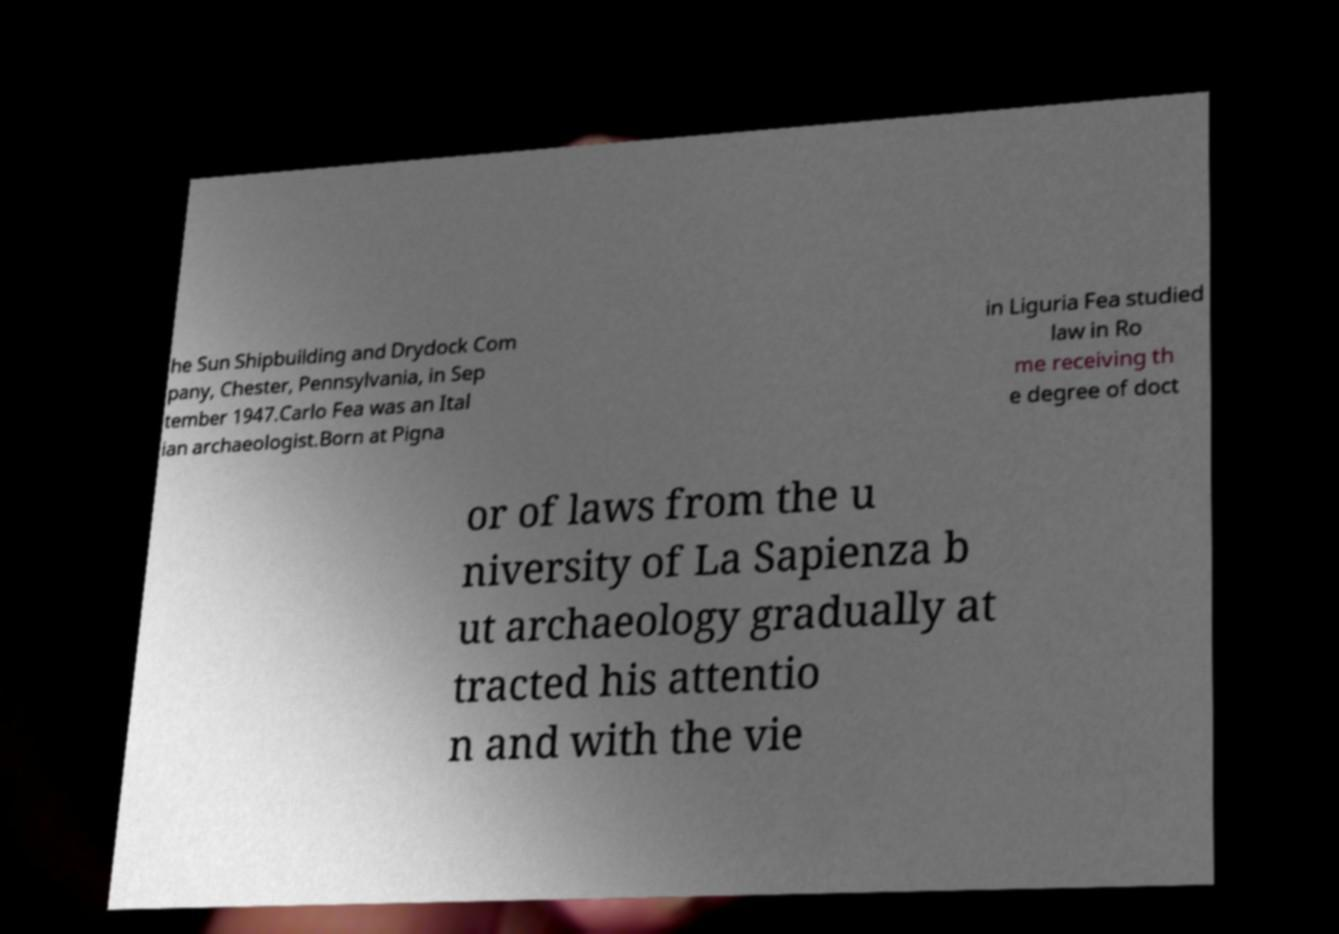For documentation purposes, I need the text within this image transcribed. Could you provide that? he Sun Shipbuilding and Drydock Com pany, Chester, Pennsylvania, in Sep tember 1947.Carlo Fea was an Ital ian archaeologist.Born at Pigna in Liguria Fea studied law in Ro me receiving th e degree of doct or of laws from the u niversity of La Sapienza b ut archaeology gradually at tracted his attentio n and with the vie 